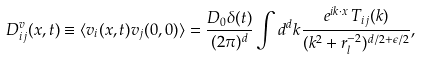<formula> <loc_0><loc_0><loc_500><loc_500>D _ { i j } ^ { v } ( { x } , t ) \equiv \langle v _ { i } ( { x } , t ) v _ { j } ( 0 , 0 ) \rangle = \frac { D _ { 0 } \delta ( t ) } { ( 2 \pi ) ^ { d } } \int d ^ { d } { k } \frac { e ^ { i { k \cdot x } } \, T _ { i j } ( { k } ) } { ( k ^ { 2 } + r _ { l } ^ { - 2 } ) ^ { d / 2 + \epsilon / 2 } } ,</formula> 